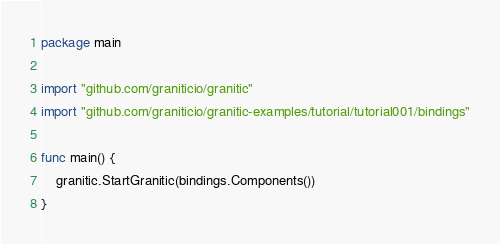Convert code to text. <code><loc_0><loc_0><loc_500><loc_500><_Go_>package main

import "github.com/graniticio/granitic"
import "github.com/graniticio/granitic-examples/tutorial/tutorial001/bindings"

func main() {
	granitic.StartGranitic(bindings.Components())
}
</code> 